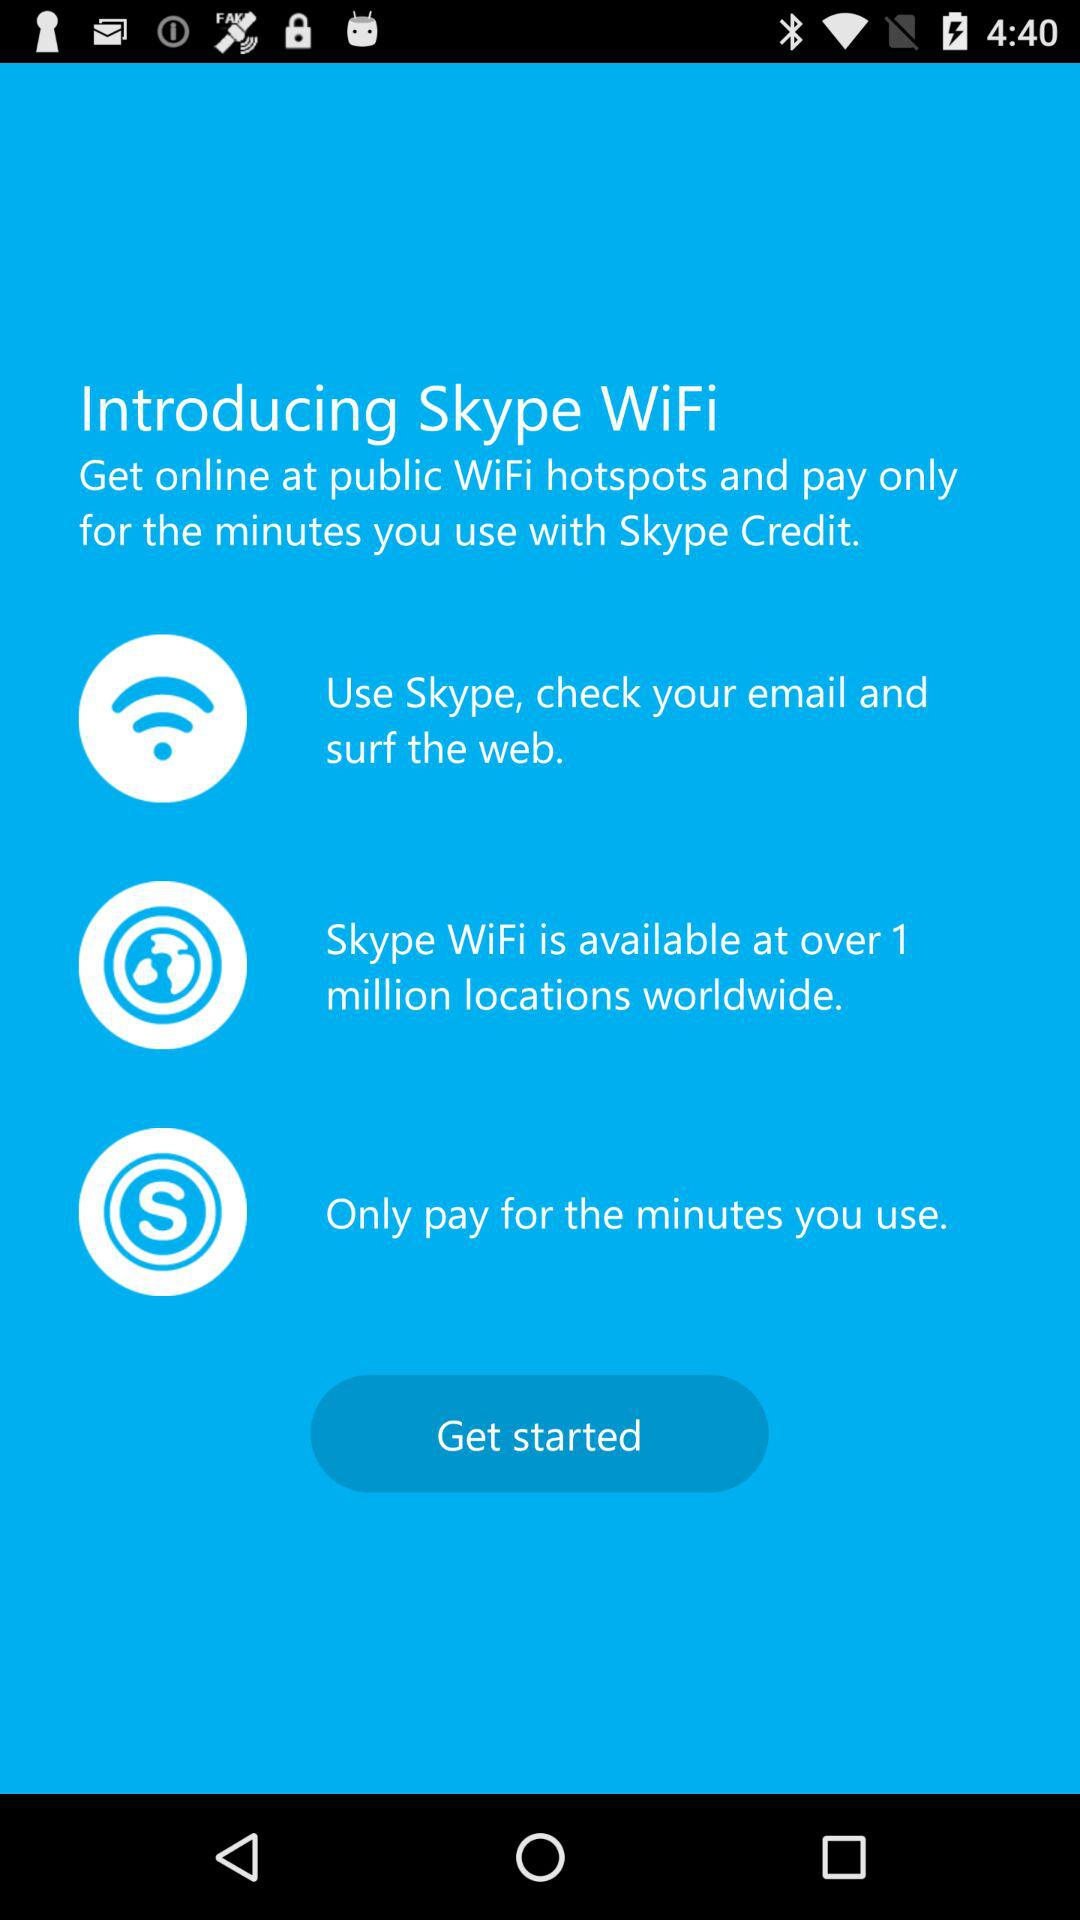How many locations worldwide does Skype WiFi have?
Answer the question using a single word or phrase. Over 1 million 